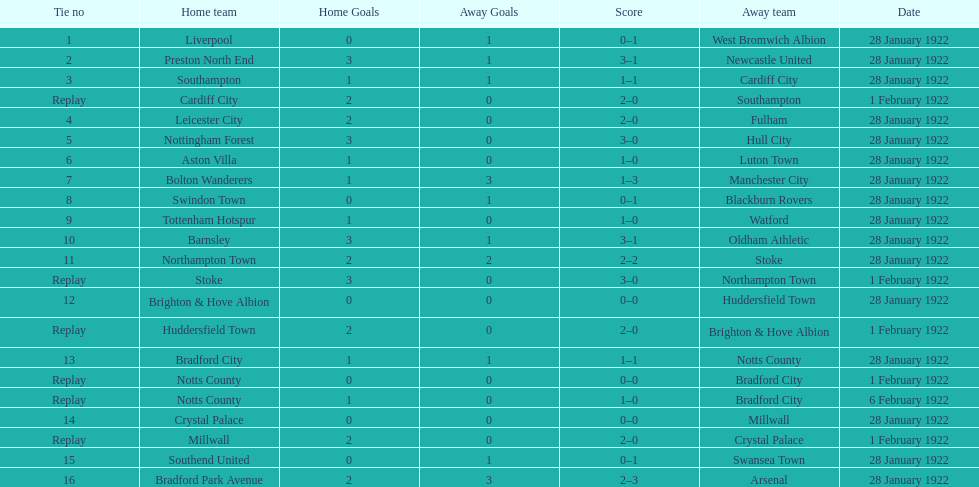How many games had four total points scored or more? 5. Write the full table. {'header': ['Tie no', 'Home team', 'Home Goals', 'Away Goals', 'Score', 'Away team', 'Date'], 'rows': [['1', 'Liverpool', '0', '1', '0–1', 'West Bromwich Albion', '28 January 1922'], ['2', 'Preston North End', '3', '1', '3–1', 'Newcastle United', '28 January 1922'], ['3', 'Southampton', '1', '1', '1–1', 'Cardiff City', '28 January 1922'], ['Replay', 'Cardiff City', '2', '0', '2–0', 'Southampton', '1 February 1922'], ['4', 'Leicester City', '2', '0', '2–0', 'Fulham', '28 January 1922'], ['5', 'Nottingham Forest', '3', '0', '3–0', 'Hull City', '28 January 1922'], ['6', 'Aston Villa', '1', '0', '1–0', 'Luton Town', '28 January 1922'], ['7', 'Bolton Wanderers', '1', '3', '1–3', 'Manchester City', '28 January 1922'], ['8', 'Swindon Town', '0', '1', '0–1', 'Blackburn Rovers', '28 January 1922'], ['9', 'Tottenham Hotspur', '1', '0', '1–0', 'Watford', '28 January 1922'], ['10', 'Barnsley', '3', '1', '3–1', 'Oldham Athletic', '28 January 1922'], ['11', 'Northampton Town', '2', '2', '2–2', 'Stoke', '28 January 1922'], ['Replay', 'Stoke', '3', '0', '3–0', 'Northampton Town', '1 February 1922'], ['12', 'Brighton & Hove Albion', '0', '0', '0–0', 'Huddersfield Town', '28 January 1922'], ['Replay', 'Huddersfield Town', '2', '0', '2–0', 'Brighton & Hove Albion', '1 February 1922'], ['13', 'Bradford City', '1', '1', '1–1', 'Notts County', '28 January 1922'], ['Replay', 'Notts County', '0', '0', '0–0', 'Bradford City', '1 February 1922'], ['Replay', 'Notts County', '1', '0', '1–0', 'Bradford City', '6 February 1922'], ['14', 'Crystal Palace', '0', '0', '0–0', 'Millwall', '28 January 1922'], ['Replay', 'Millwall', '2', '0', '2–0', 'Crystal Palace', '1 February 1922'], ['15', 'Southend United', '0', '1', '0–1', 'Swansea Town', '28 January 1922'], ['16', 'Bradford Park Avenue', '2', '3', '2–3', 'Arsenal', '28 January 1922']]} 